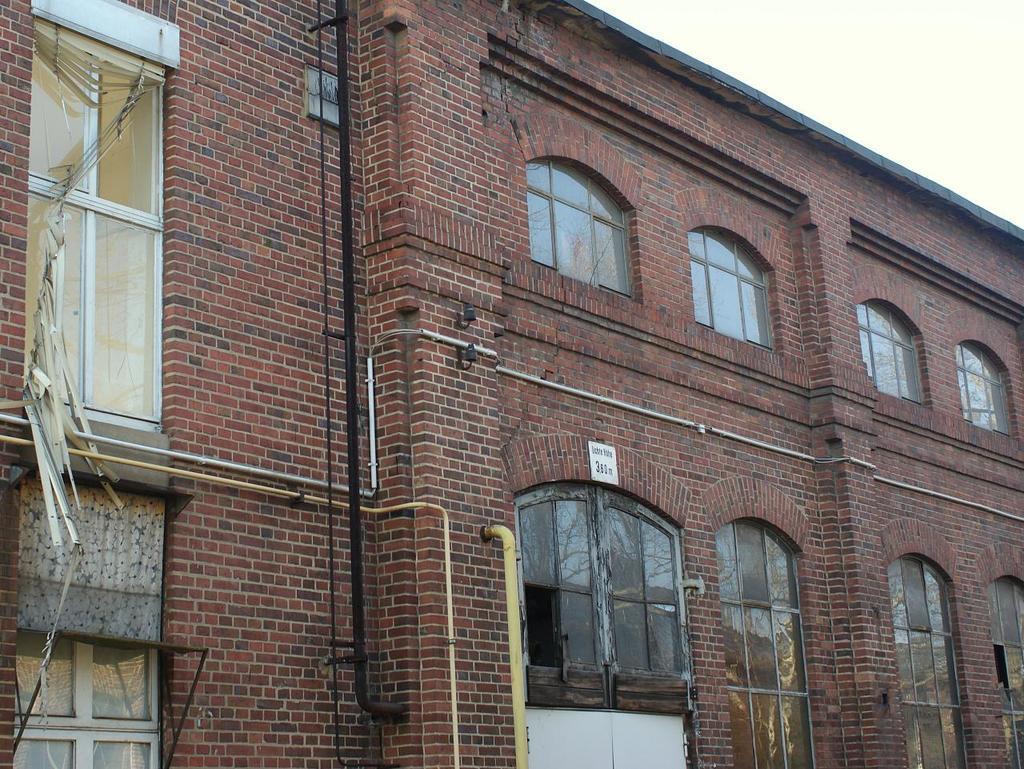Please provide a concise description of this image. In this image I can see it is a building with glass windows. In the middle there is a pipe in yellow color. At the top it is the sky. 